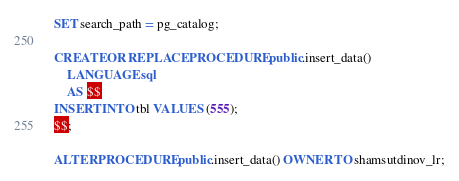<code> <loc_0><loc_0><loc_500><loc_500><_SQL_>SET search_path = pg_catalog;

CREATE OR REPLACE PROCEDURE public.insert_data()
    LANGUAGE sql
    AS $$
INSERT INTO tbl VALUES (555);
$$;

ALTER PROCEDURE public.insert_data() OWNER TO shamsutdinov_lr;</code> 